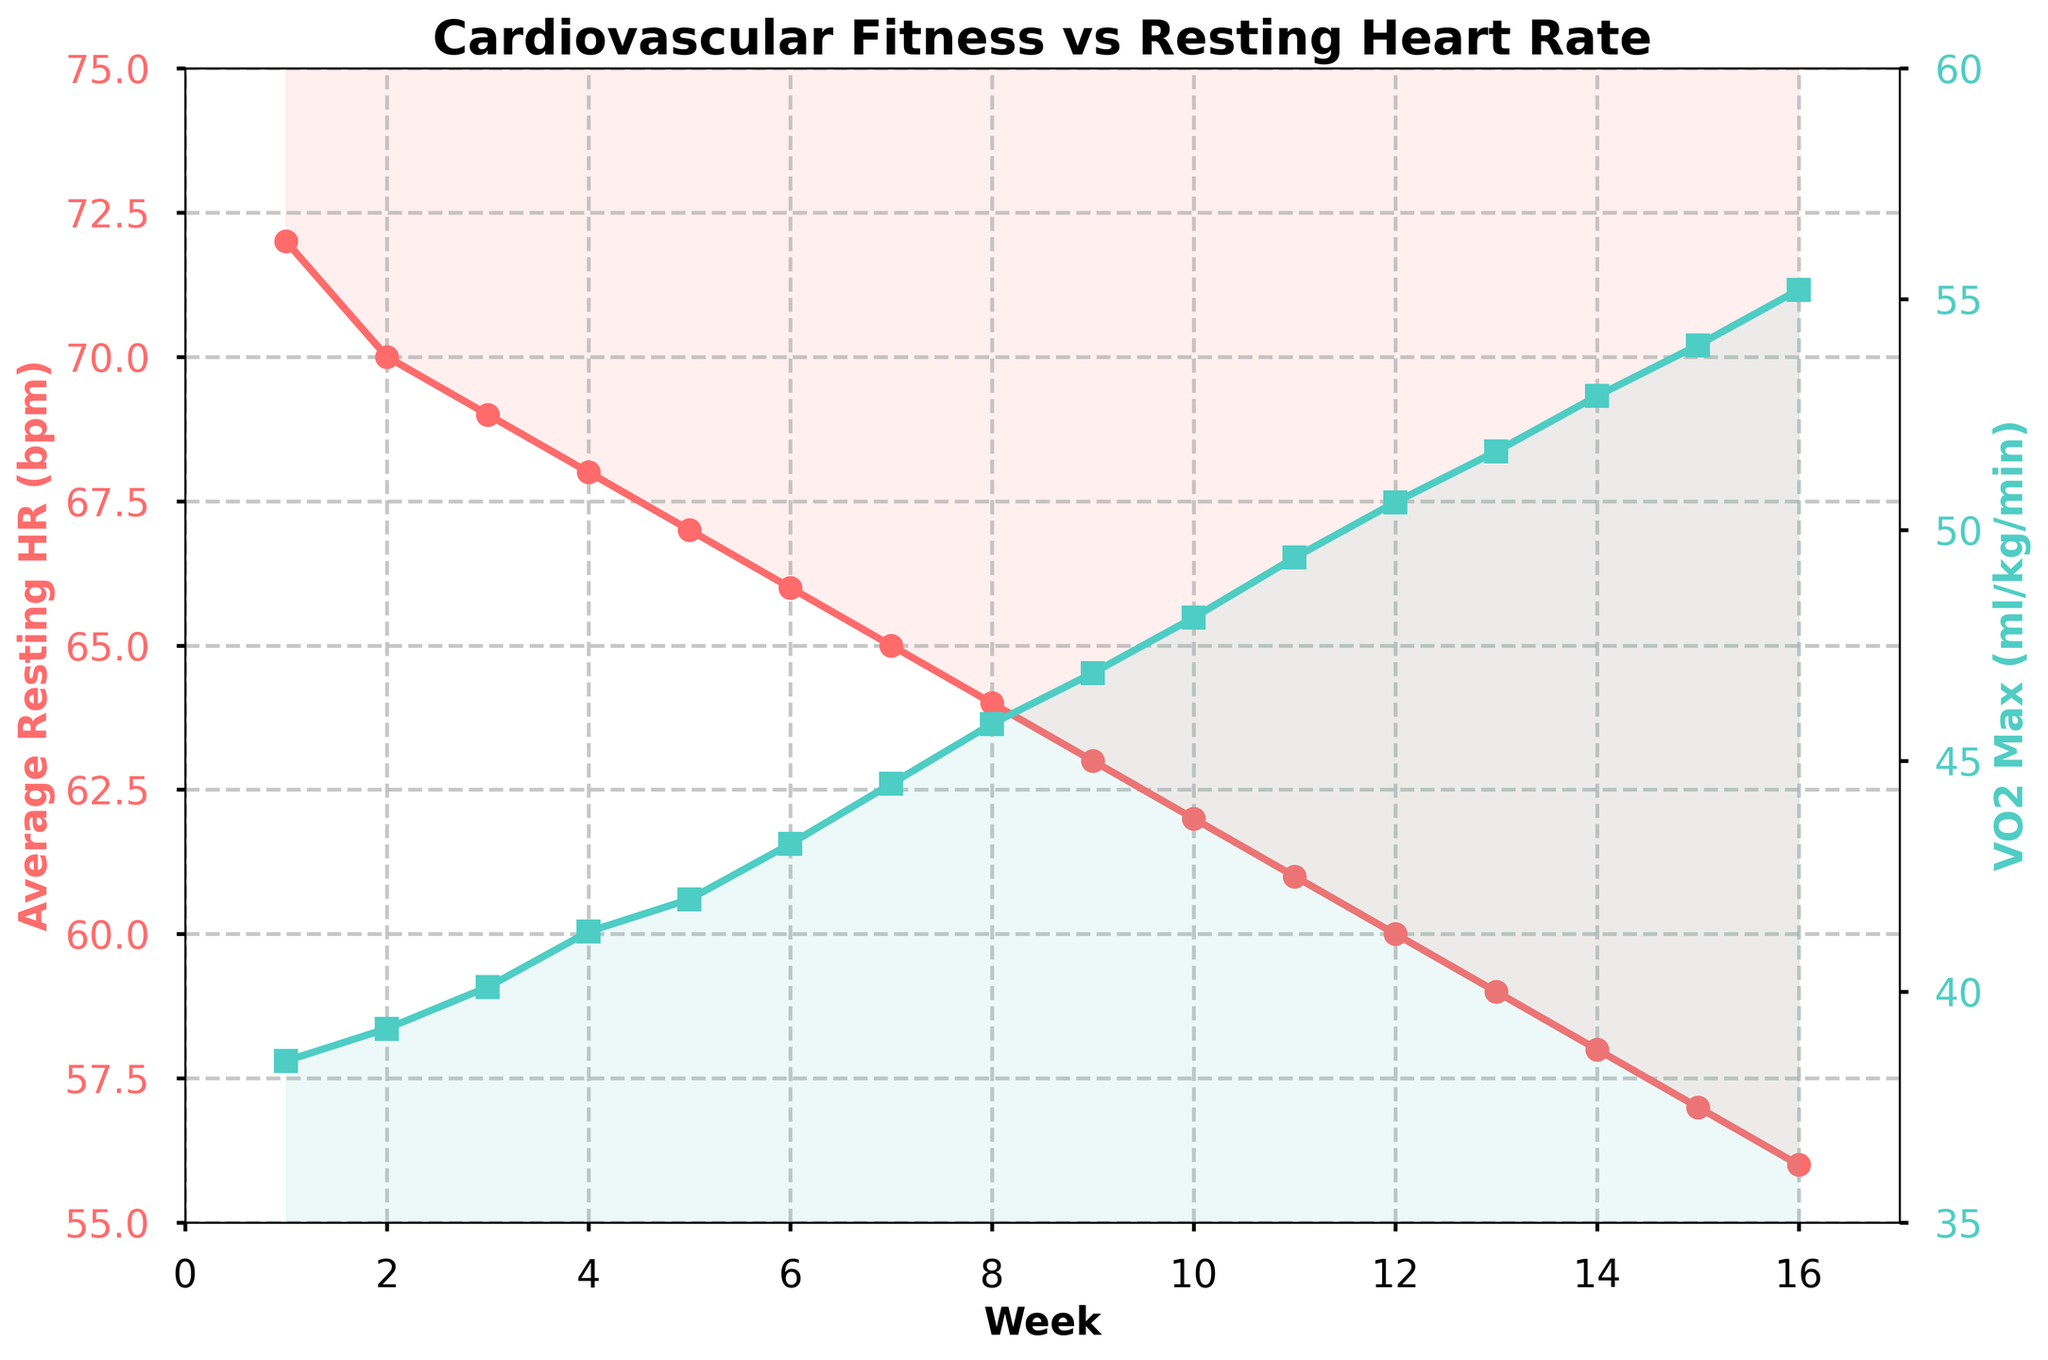What's the trend in Average Resting HR over the 16-week training period? To determine the trend in Average Resting HR, observe the line representing this metric across the 16 weeks. Notice that the Average Resting HR decreases steadily from 72 bpm in Week 1 to 56 bpm in Week 16.
Answer: Decreasing What is the difference between the VO2 Max in Week 1 and Week 16? To find the difference, subtract the VO2 Max value at Week 1 from the VO2 Max value at Week 16. VO2 Max at Week 16 is 55.2, and at Week 1, it is 38.5. The difference is \(55.2 - 38.5 = 16.7\).
Answer: 16.7 ml/kg/min Compare the rates of change for Average Resting HR and VO2 Max between Week 8 and Week 12. Which one changes more rapidly? First, compute the changes in both metrics between Week 8 and Week 12. For Average Resting HR: \(64 - 60 = 4\) bpm. For VO2 Max: \(45.8 - 50.6 = 4.8\) ml/kg/min. The VO2 Max changes more rapidly (4.8 units) compared to the Average Resting HR (4 units).
Answer: VO2 Max During which week does the Average Resting HR drop below 60 bpm for the first time? Look at the line chart for Average Resting HR and identify the point where it first dips below 60 bpm. This occurs at Week 12, where the value is exactly 60 bpm. Hence, the first drop below 60 bpm is in Week 13.
Answer: Week 13 What is the average VO2 Max over the entire 16-week period? To find the average VO2 Max, sum the values of VO2 Max across all 16 weeks and divide by 16. The sum of VO2 Max values is \(38.5 + 39.2 + ... + 55.2 = 780.6\). So, the average is \(780.6 / 16 = 48.79\).
Answer: 48.79 ml/kg/min How does the color of the lines help differentiate between Average Resting HR and VO2 Max? The colors of the lines visually distinguish the two metrics: the line for Average Resting HR is red, while the line for VO2 Max is green. This color coding helps easily identify and compare the two data series.
Answer: Red and green Compare the resting heart rate in Week 1 and Week 9. By what percentage did it change? Calculate the percentage change using the formula \((\text{New Value} - \text{Old Value}) / \text{Old Value} \times 100\). For Week 1 and Week 9: \((63 - 72) / 72 \times 100 = -12.5\%\). Thus, there is a 12.5% decrease.
Answer: -12.5% If the trend continues, what would you predict the Average Resting HR to be in Week 20? By extending the observed trend linearly, estimate the decrease per week from Week 1 to Week 16. The total decrease is \(72 - 56 = 16\) bpm over 16 weeks, or 1 bpm per week. Therefore, at Week 20, it would be \(56 - 4 = 52\) bpm.
Answer: 52 bpm 